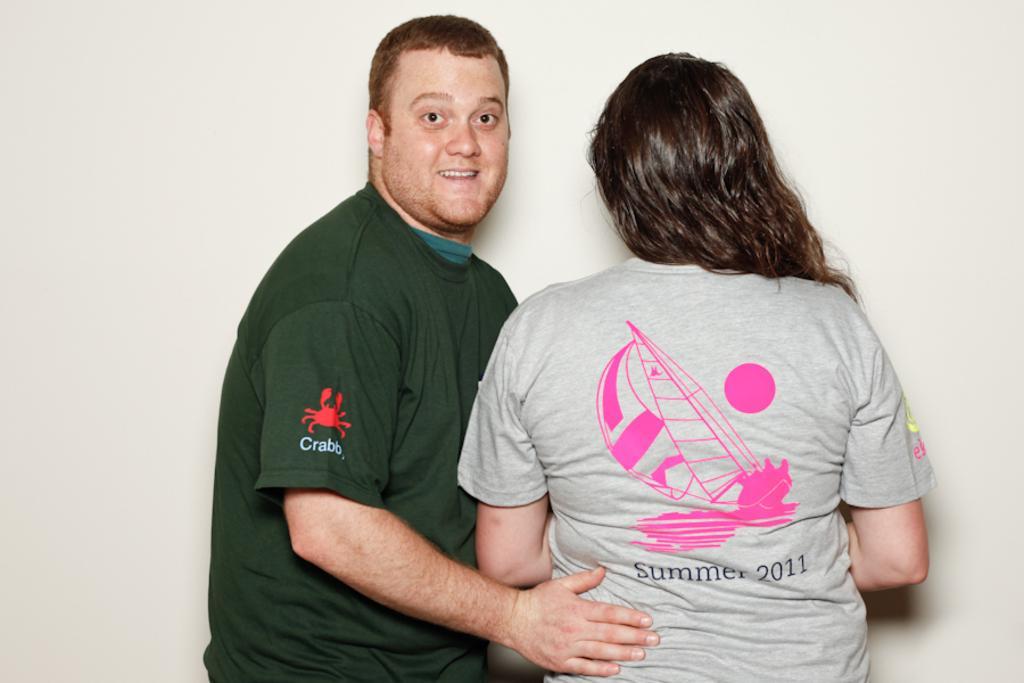How would you summarize this image in a sentence or two? On the left there is a man who is wearing t-shirt and putting his hand on this woman. She is wearing t-shirt. Both of them are standing near to the wall. 